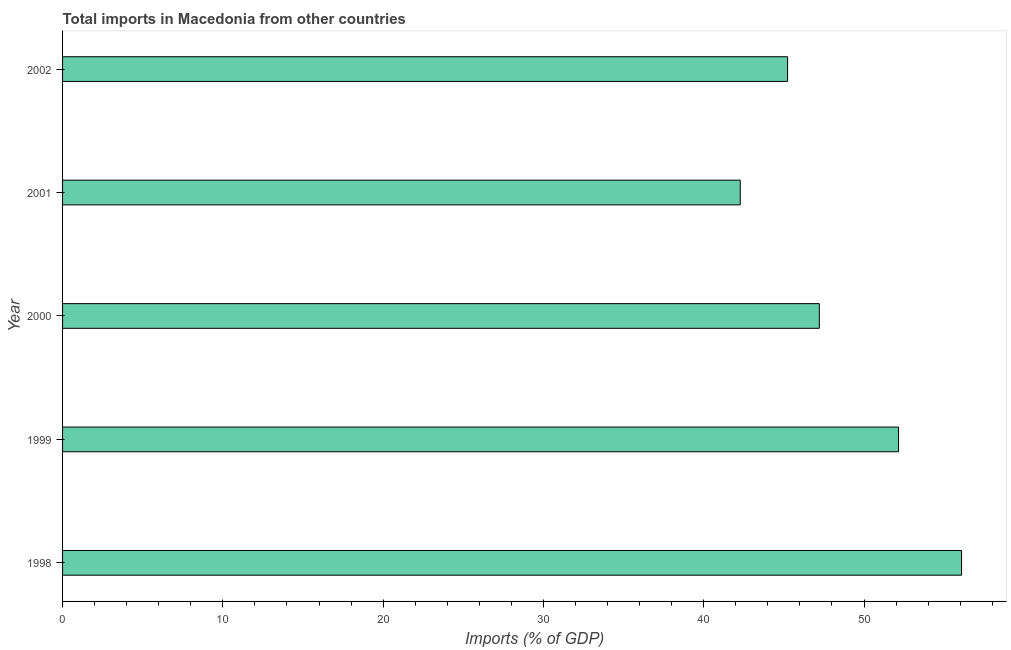Does the graph contain any zero values?
Keep it short and to the point. No. What is the title of the graph?
Provide a succinct answer. Total imports in Macedonia from other countries. What is the label or title of the X-axis?
Ensure brevity in your answer.  Imports (% of GDP). What is the label or title of the Y-axis?
Provide a succinct answer. Year. What is the total imports in 1998?
Your answer should be very brief. 56.09. Across all years, what is the maximum total imports?
Provide a succinct answer. 56.09. Across all years, what is the minimum total imports?
Give a very brief answer. 42.28. In which year was the total imports minimum?
Your answer should be very brief. 2001. What is the sum of the total imports?
Offer a very short reply. 242.96. What is the difference between the total imports in 1999 and 2001?
Your answer should be very brief. 9.87. What is the average total imports per year?
Give a very brief answer. 48.59. What is the median total imports?
Provide a succinct answer. 47.21. In how many years, is the total imports greater than 32 %?
Provide a succinct answer. 5. Do a majority of the years between 1999 and 2000 (inclusive) have total imports greater than 8 %?
Your answer should be very brief. Yes. What is the ratio of the total imports in 2000 to that in 2002?
Your answer should be compact. 1.04. Is the difference between the total imports in 2000 and 2001 greater than the difference between any two years?
Give a very brief answer. No. What is the difference between the highest and the second highest total imports?
Keep it short and to the point. 3.93. What is the difference between the highest and the lowest total imports?
Provide a short and direct response. 13.81. How many bars are there?
Ensure brevity in your answer.  5. What is the difference between two consecutive major ticks on the X-axis?
Your response must be concise. 10. Are the values on the major ticks of X-axis written in scientific E-notation?
Offer a very short reply. No. What is the Imports (% of GDP) in 1998?
Offer a very short reply. 56.09. What is the Imports (% of GDP) in 1999?
Your answer should be very brief. 52.15. What is the Imports (% of GDP) of 2000?
Provide a short and direct response. 47.21. What is the Imports (% of GDP) of 2001?
Your answer should be compact. 42.28. What is the Imports (% of GDP) of 2002?
Offer a terse response. 45.23. What is the difference between the Imports (% of GDP) in 1998 and 1999?
Your answer should be very brief. 3.93. What is the difference between the Imports (% of GDP) in 1998 and 2000?
Make the answer very short. 8.87. What is the difference between the Imports (% of GDP) in 1998 and 2001?
Keep it short and to the point. 13.81. What is the difference between the Imports (% of GDP) in 1998 and 2002?
Your response must be concise. 10.85. What is the difference between the Imports (% of GDP) in 1999 and 2000?
Ensure brevity in your answer.  4.94. What is the difference between the Imports (% of GDP) in 1999 and 2001?
Provide a succinct answer. 9.87. What is the difference between the Imports (% of GDP) in 1999 and 2002?
Provide a succinct answer. 6.92. What is the difference between the Imports (% of GDP) in 2000 and 2001?
Your response must be concise. 4.93. What is the difference between the Imports (% of GDP) in 2000 and 2002?
Keep it short and to the point. 1.98. What is the difference between the Imports (% of GDP) in 2001 and 2002?
Make the answer very short. -2.95. What is the ratio of the Imports (% of GDP) in 1998 to that in 1999?
Provide a short and direct response. 1.07. What is the ratio of the Imports (% of GDP) in 1998 to that in 2000?
Make the answer very short. 1.19. What is the ratio of the Imports (% of GDP) in 1998 to that in 2001?
Ensure brevity in your answer.  1.33. What is the ratio of the Imports (% of GDP) in 1998 to that in 2002?
Ensure brevity in your answer.  1.24. What is the ratio of the Imports (% of GDP) in 1999 to that in 2000?
Your response must be concise. 1.1. What is the ratio of the Imports (% of GDP) in 1999 to that in 2001?
Your response must be concise. 1.23. What is the ratio of the Imports (% of GDP) in 1999 to that in 2002?
Give a very brief answer. 1.15. What is the ratio of the Imports (% of GDP) in 2000 to that in 2001?
Make the answer very short. 1.12. What is the ratio of the Imports (% of GDP) in 2000 to that in 2002?
Keep it short and to the point. 1.04. What is the ratio of the Imports (% of GDP) in 2001 to that in 2002?
Ensure brevity in your answer.  0.94. 